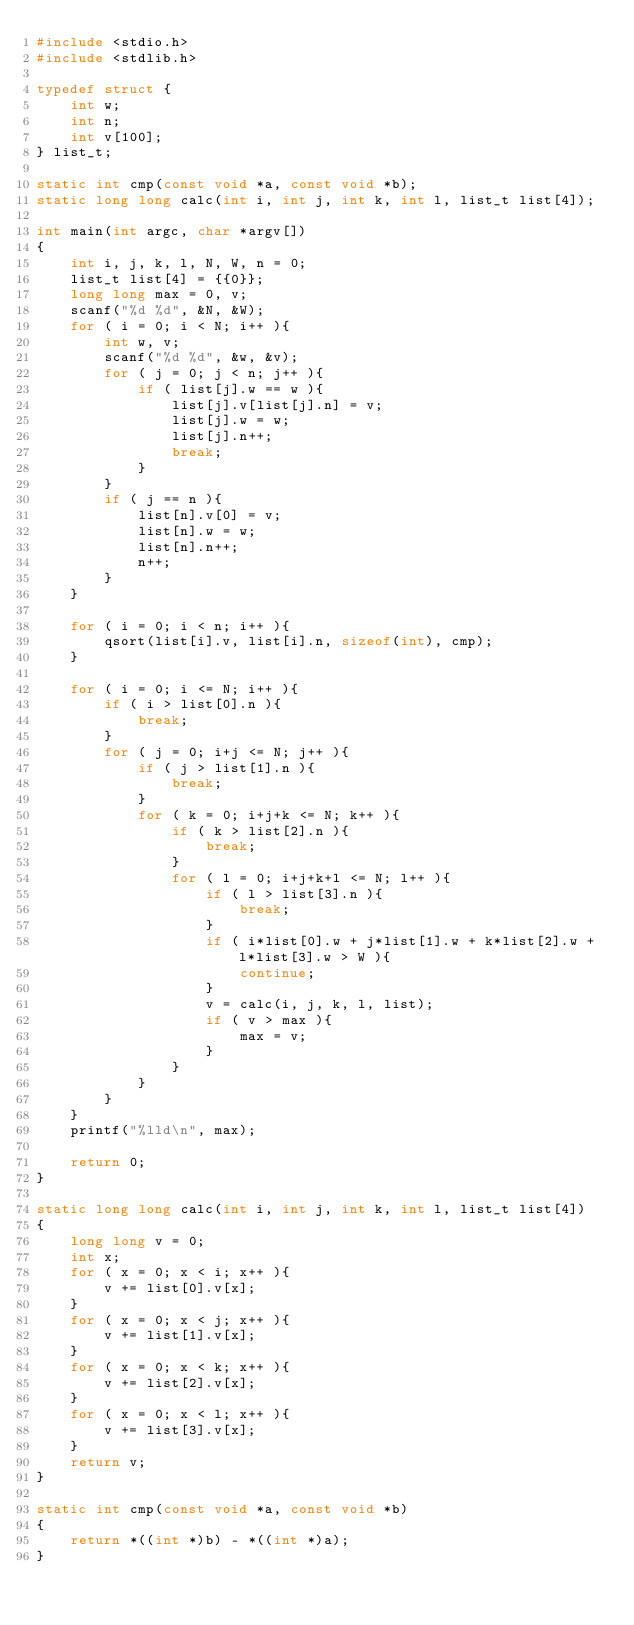Convert code to text. <code><loc_0><loc_0><loc_500><loc_500><_C_>#include <stdio.h>
#include <stdlib.h>

typedef struct {
	int w;
	int n;
	int v[100];
} list_t;

static int cmp(const void *a, const void *b);
static long long calc(int i, int j, int k, int l, list_t list[4]);

int main(int argc, char *argv[])
{
	int i, j, k, l, N, W, n = 0;
	list_t list[4] = {{0}};
	long long max = 0, v;
	scanf("%d %d", &N, &W);
	for ( i = 0; i < N; i++ ){
		int w, v;
		scanf("%d %d", &w, &v);
		for ( j = 0; j < n; j++ ){
			if ( list[j].w == w ){
				list[j].v[list[j].n] = v;
				list[j].w = w;
				list[j].n++;
				break;
			}
		}
		if ( j == n ){
			list[n].v[0] = v;
			list[n].w = w;
			list[n].n++;
			n++;
		}
	}

	for ( i = 0; i < n; i++ ){
		qsort(list[i].v, list[i].n, sizeof(int), cmp);
	}

	for ( i = 0; i <= N; i++ ){
		if ( i > list[0].n ){
			break;
		}
		for ( j = 0; i+j <= N; j++ ){
			if ( j > list[1].n ){
				break;
			}
			for ( k = 0; i+j+k <= N; k++ ){
				if ( k > list[2].n ){
					break;
				}
				for ( l = 0; i+j+k+l <= N; l++ ){
					if ( l > list[3].n ){
						break;
					}
					if ( i*list[0].w + j*list[1].w + k*list[2].w + l*list[3].w > W ){
						continue;
					}
					v = calc(i, j, k, l, list);
					if ( v > max ){
						max = v;
					}
				}
			}
		}
	}
	printf("%lld\n", max);

	return 0;
}

static long long calc(int i, int j, int k, int l, list_t list[4])
{
	long long v = 0;
	int x;
	for ( x = 0; x < i; x++ ){
		v += list[0].v[x];
	}
	for ( x = 0; x < j; x++ ){
		v += list[1].v[x];
	}
	for ( x = 0; x < k; x++ ){
		v += list[2].v[x];
	}
	for ( x = 0; x < l; x++ ){
		v += list[3].v[x];
	}
	return v;
}

static int cmp(const void *a, const void *b)
{
	return *((int *)b) - *((int *)a);
}
</code> 